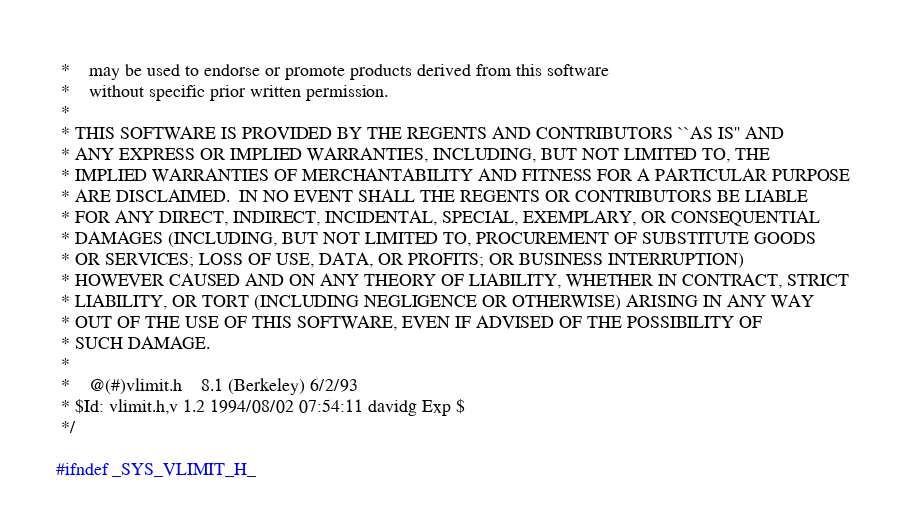<code> <loc_0><loc_0><loc_500><loc_500><_C_> *    may be used to endorse or promote products derived from this software
 *    without specific prior written permission.
 *
 * THIS SOFTWARE IS PROVIDED BY THE REGENTS AND CONTRIBUTORS ``AS IS'' AND
 * ANY EXPRESS OR IMPLIED WARRANTIES, INCLUDING, BUT NOT LIMITED TO, THE
 * IMPLIED WARRANTIES OF MERCHANTABILITY AND FITNESS FOR A PARTICULAR PURPOSE
 * ARE DISCLAIMED.  IN NO EVENT SHALL THE REGENTS OR CONTRIBUTORS BE LIABLE
 * FOR ANY DIRECT, INDIRECT, INCIDENTAL, SPECIAL, EXEMPLARY, OR CONSEQUENTIAL
 * DAMAGES (INCLUDING, BUT NOT LIMITED TO, PROCUREMENT OF SUBSTITUTE GOODS
 * OR SERVICES; LOSS OF USE, DATA, OR PROFITS; OR BUSINESS INTERRUPTION)
 * HOWEVER CAUSED AND ON ANY THEORY OF LIABILITY, WHETHER IN CONTRACT, STRICT
 * LIABILITY, OR TORT (INCLUDING NEGLIGENCE OR OTHERWISE) ARISING IN ANY WAY
 * OUT OF THE USE OF THIS SOFTWARE, EVEN IF ADVISED OF THE POSSIBILITY OF
 * SUCH DAMAGE.
 *
 *	@(#)vlimit.h	8.1 (Berkeley) 6/2/93
 * $Id: vlimit.h,v 1.2 1994/08/02 07:54:11 davidg Exp $
 */

#ifndef _SYS_VLIMIT_H_</code> 